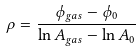<formula> <loc_0><loc_0><loc_500><loc_500>\rho = \frac { \phi _ { g a s } - \phi _ { 0 } } { \ln A _ { g a s } - \ln A _ { 0 } }</formula> 